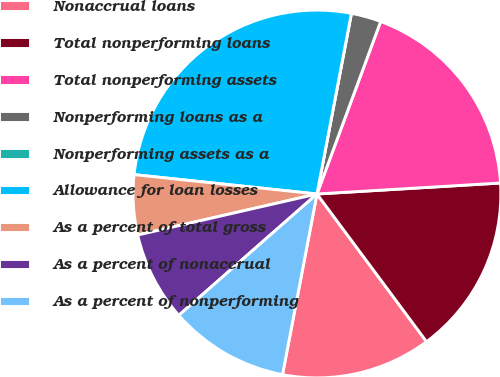Convert chart. <chart><loc_0><loc_0><loc_500><loc_500><pie_chart><fcel>Nonaccrual loans<fcel>Total nonperforming loans<fcel>Total nonperforming assets<fcel>Nonperforming loans as a<fcel>Nonperforming assets as a<fcel>Allowance for loan losses<fcel>As a percent of total gross<fcel>As a percent of nonaccrual<fcel>As a percent of nonperforming<nl><fcel>13.16%<fcel>15.79%<fcel>18.42%<fcel>2.63%<fcel>0.0%<fcel>26.32%<fcel>5.26%<fcel>7.89%<fcel>10.53%<nl></chart> 